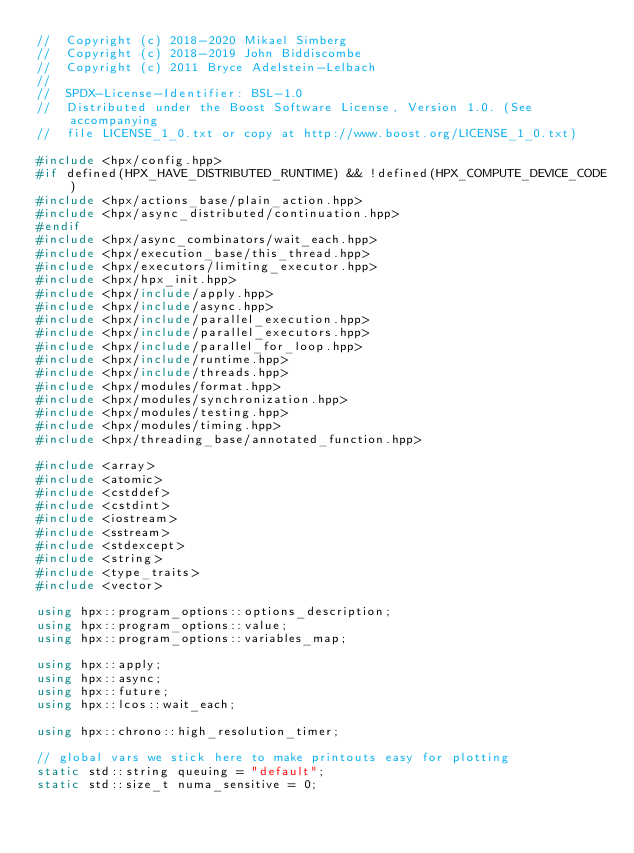<code> <loc_0><loc_0><loc_500><loc_500><_C++_>//  Copyright (c) 2018-2020 Mikael Simberg
//  Copyright (c) 2018-2019 John Biddiscombe
//  Copyright (c) 2011 Bryce Adelstein-Lelbach
//
//  SPDX-License-Identifier: BSL-1.0
//  Distributed under the Boost Software License, Version 1.0. (See accompanying
//  file LICENSE_1_0.txt or copy at http://www.boost.org/LICENSE_1_0.txt)

#include <hpx/config.hpp>
#if defined(HPX_HAVE_DISTRIBUTED_RUNTIME) && !defined(HPX_COMPUTE_DEVICE_CODE)
#include <hpx/actions_base/plain_action.hpp>
#include <hpx/async_distributed/continuation.hpp>
#endif
#include <hpx/async_combinators/wait_each.hpp>
#include <hpx/execution_base/this_thread.hpp>
#include <hpx/executors/limiting_executor.hpp>
#include <hpx/hpx_init.hpp>
#include <hpx/include/apply.hpp>
#include <hpx/include/async.hpp>
#include <hpx/include/parallel_execution.hpp>
#include <hpx/include/parallel_executors.hpp>
#include <hpx/include/parallel_for_loop.hpp>
#include <hpx/include/runtime.hpp>
#include <hpx/include/threads.hpp>
#include <hpx/modules/format.hpp>
#include <hpx/modules/synchronization.hpp>
#include <hpx/modules/testing.hpp>
#include <hpx/modules/timing.hpp>
#include <hpx/threading_base/annotated_function.hpp>

#include <array>
#include <atomic>
#include <cstddef>
#include <cstdint>
#include <iostream>
#include <sstream>
#include <stdexcept>
#include <string>
#include <type_traits>
#include <vector>

using hpx::program_options::options_description;
using hpx::program_options::value;
using hpx::program_options::variables_map;

using hpx::apply;
using hpx::async;
using hpx::future;
using hpx::lcos::wait_each;

using hpx::chrono::high_resolution_timer;

// global vars we stick here to make printouts easy for plotting
static std::string queuing = "default";
static std::size_t numa_sensitive = 0;</code> 